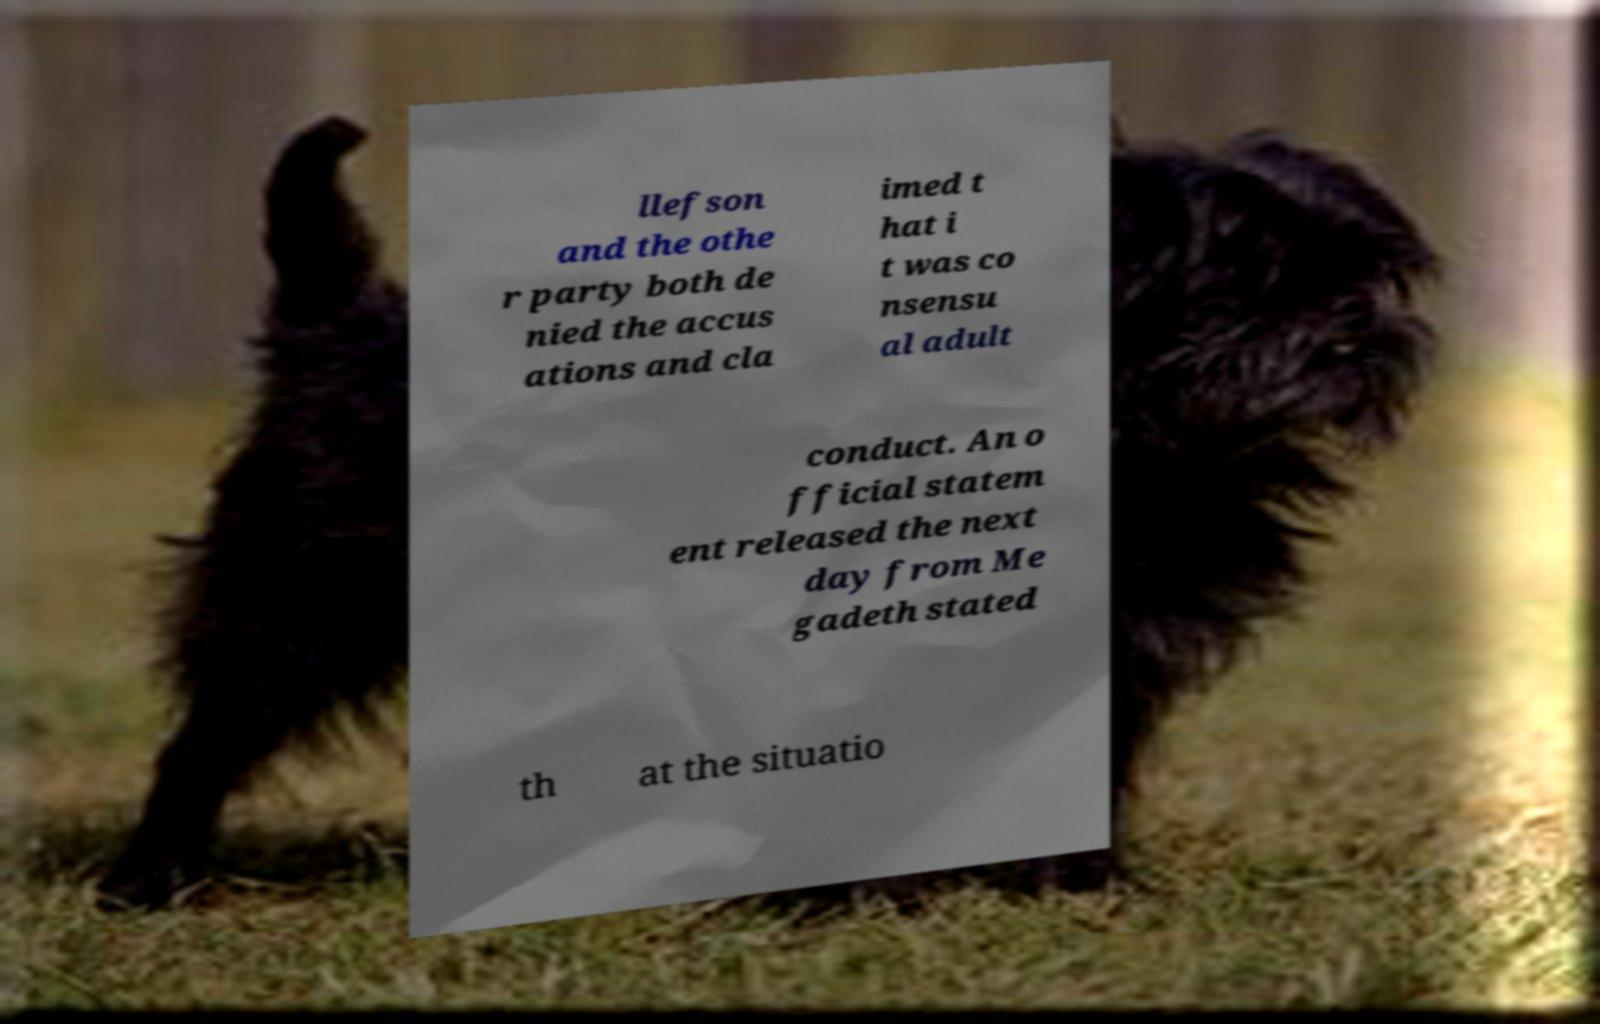For documentation purposes, I need the text within this image transcribed. Could you provide that? llefson and the othe r party both de nied the accus ations and cla imed t hat i t was co nsensu al adult conduct. An o fficial statem ent released the next day from Me gadeth stated th at the situatio 